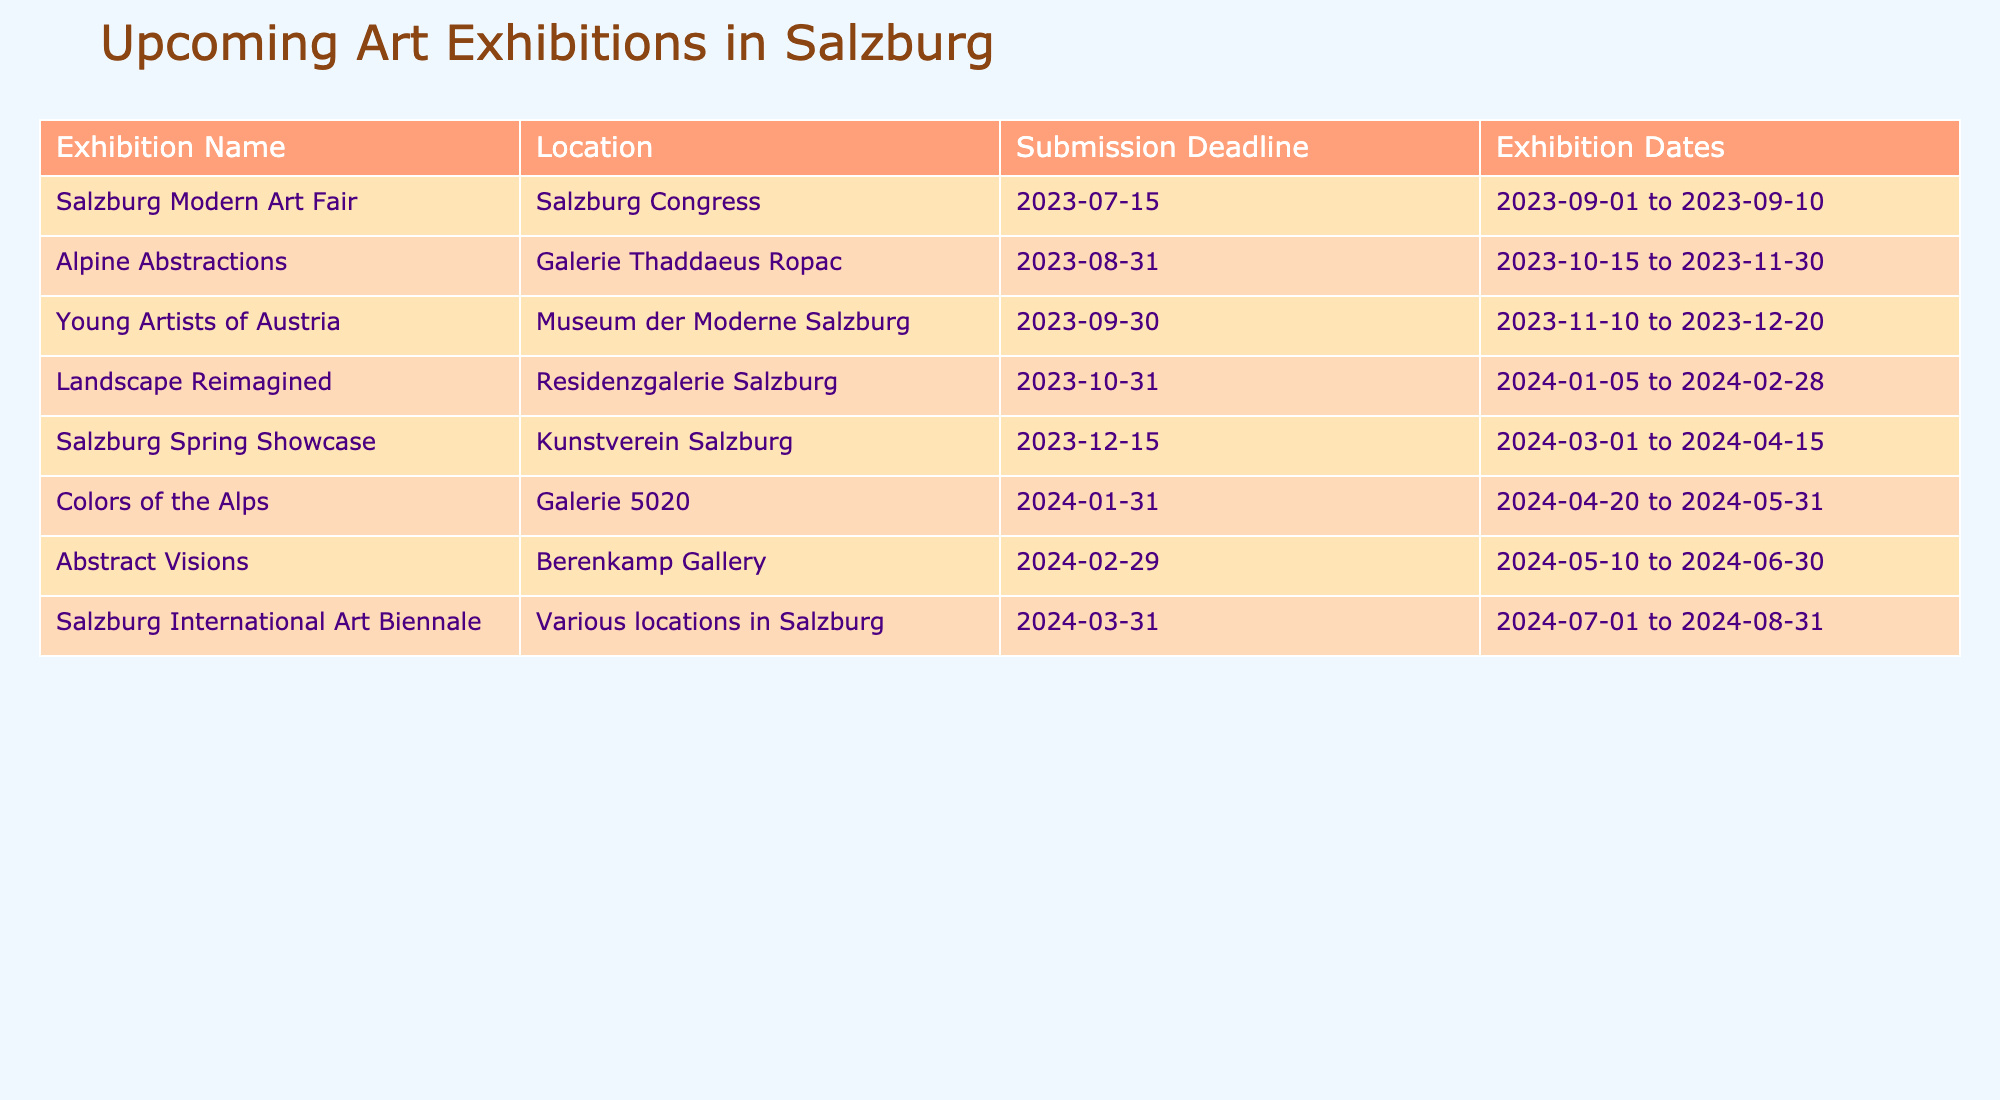What is the submission deadline for the exhibition "Landscape Reimagined"? According to the table, the submission deadline for "Landscape Reimagined" is listed under the Submission Deadline column. It is stated as 2023-10-31.
Answer: 2023-10-31 How many different locations are hosting art exhibitions based on the table? The table lists five unique locations: Salzburg Congress, Galerie Thaddaeus Ropac, Museum der Moderne Salzburg, Residenzgalerie Salzburg, and Kunstverein Salzburg. When counting each unique location, we have a total of six, including the category of "Various locations in Salzburg" for the Salzburg International Art Biennale.
Answer: 6 What is the last exhibition date before the Salzburg Spring Showcase? The Salzburg Spring Showcase runs from 2024-03-01 to 2024-04-15. Looking at the previous exhibitions in the table, the last exhibition before this is "Young Artists of Austria," which runs from 2023-11-10 to 2023-12-20. Therefore, the last exhibition date before the Spring Showcase is 2023-12-20.
Answer: 2023-12-20 Is the exhibition "Abstract Visions" scheduled before or after "Colors of the Alps"? "Colors of the Alps" runs from 2024-04-20 to 2024-05-31, while "Abstract Visions" is from 2024-05-10 to 2024-06-30. On comparing the dates, "Abstract Visions" starts on 2024-05-10, which is after the last date for "Colors of the Alps" (2024-05-31). Thus, it indicates that "Abstract Visions" is scheduled after "Colors of the Alps."
Answer: After What is the time span (in days) of the exhibition "Alpine Abstractions"? The exhibition "Alpine Abstractions" runs from 2023-10-15 to 2023-11-30. To find the time span, we calculate the number of days between these two dates. Counting the days, we find it is 46 days long.
Answer: 46 days 